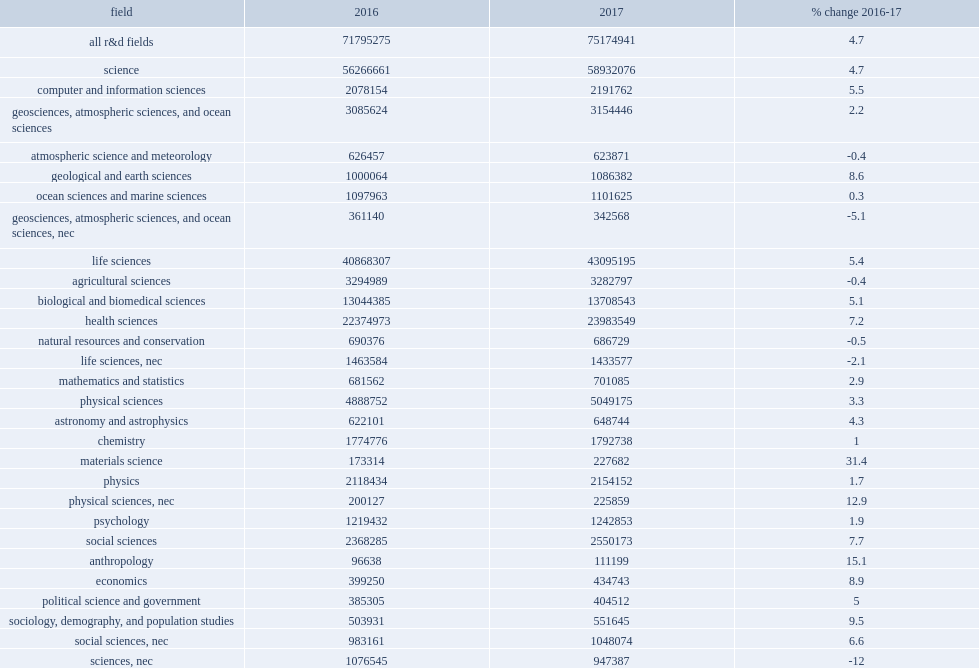How many thousand dollars was r&d expenditures in science in fy 2017? 58932076.0. How many thousand dollars was r&d expenditures in engineering in fy 2017? 11897397.0. How many thousand dollars was r&d expenditures in non-science and engineering (non-s&e) in fy 2017? 4345468.0. 